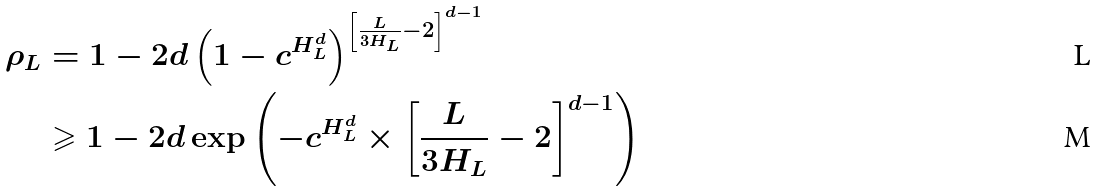<formula> <loc_0><loc_0><loc_500><loc_500>\rho _ { L } & = 1 - 2 d \left ( 1 - c ^ { H _ { L } ^ { d } } \right ) ^ { \left [ \frac { L } { 3 H _ { L } } - 2 \right ] ^ { d - 1 } } \\ & \geqslant 1 - 2 d \exp \left ( - c ^ { H _ { L } ^ { d } } \times \left [ \frac { L } { 3 H _ { L } } - 2 \right ] ^ { d - 1 } \right )</formula> 